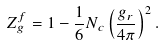<formula> <loc_0><loc_0><loc_500><loc_500>Z ^ { f } _ { g } = 1 - \frac { 1 } { 6 } N _ { c } \left ( \frac { g _ { r } } { 4 \pi } \right ) ^ { 2 } .</formula> 